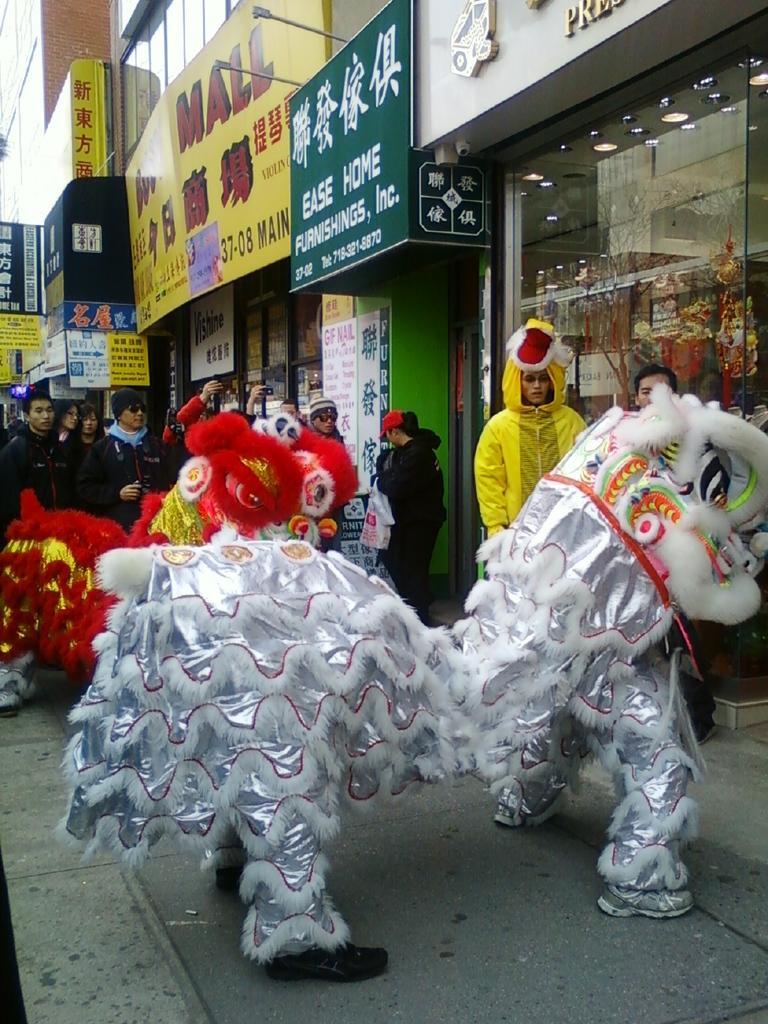Please provide a concise description of this image. This picture is taken from outside of the city. In this image, in the middle, we can see a person wearing an animal mask. On the right side, we can also see two people, in that one person wearing an animal mask which is in yellow color. On the left side, we can also see another wearing an animal mask. In the background, we can see a group of people. On the right side, we can see a glass door, hoardings, brick wall. At the bottom, we can see a floor. 